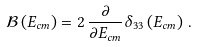Convert formula to latex. <formula><loc_0><loc_0><loc_500><loc_500>\mathcal { B } \left ( E _ { c m } \right ) = 2 \, \frac { \partial } { \partial E _ { c m } } \delta _ { 3 3 } \left ( E _ { c m } \right ) \, .</formula> 